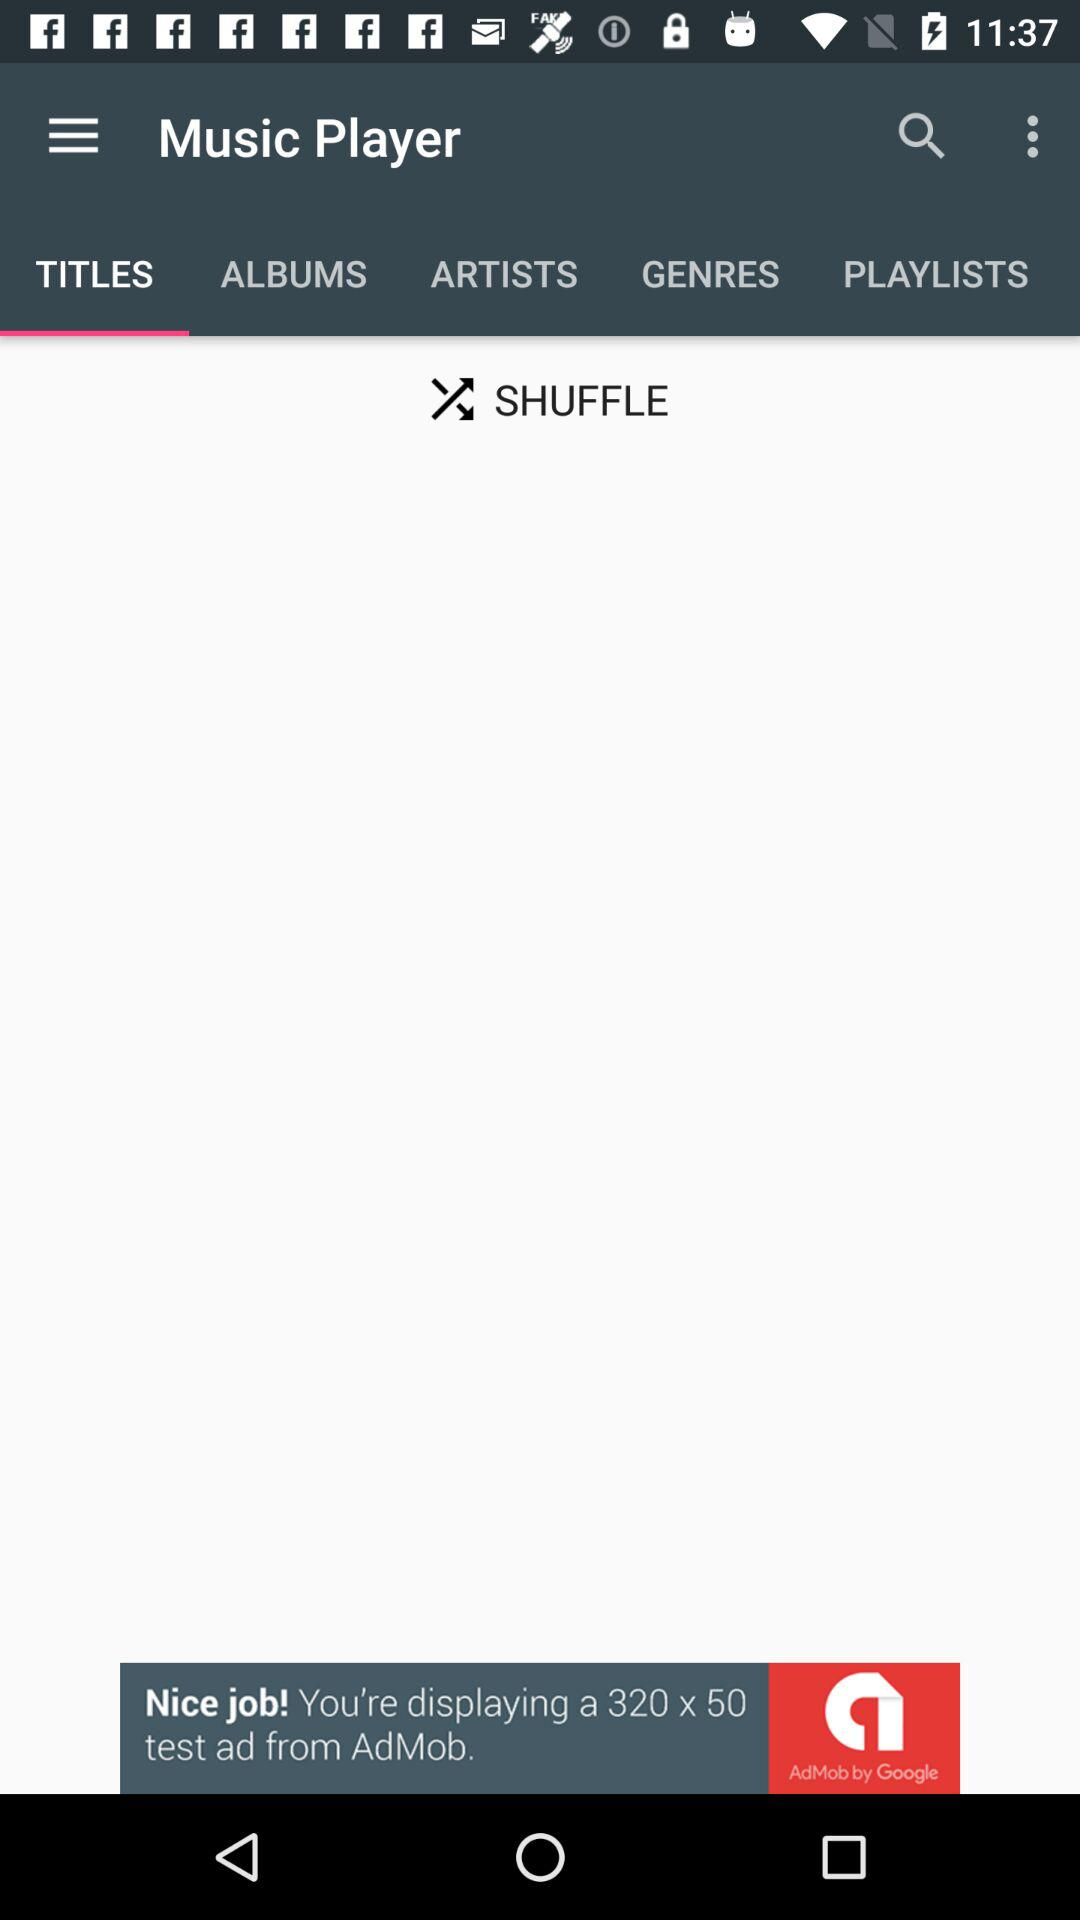What is the application name? The application name is "Music Player". 